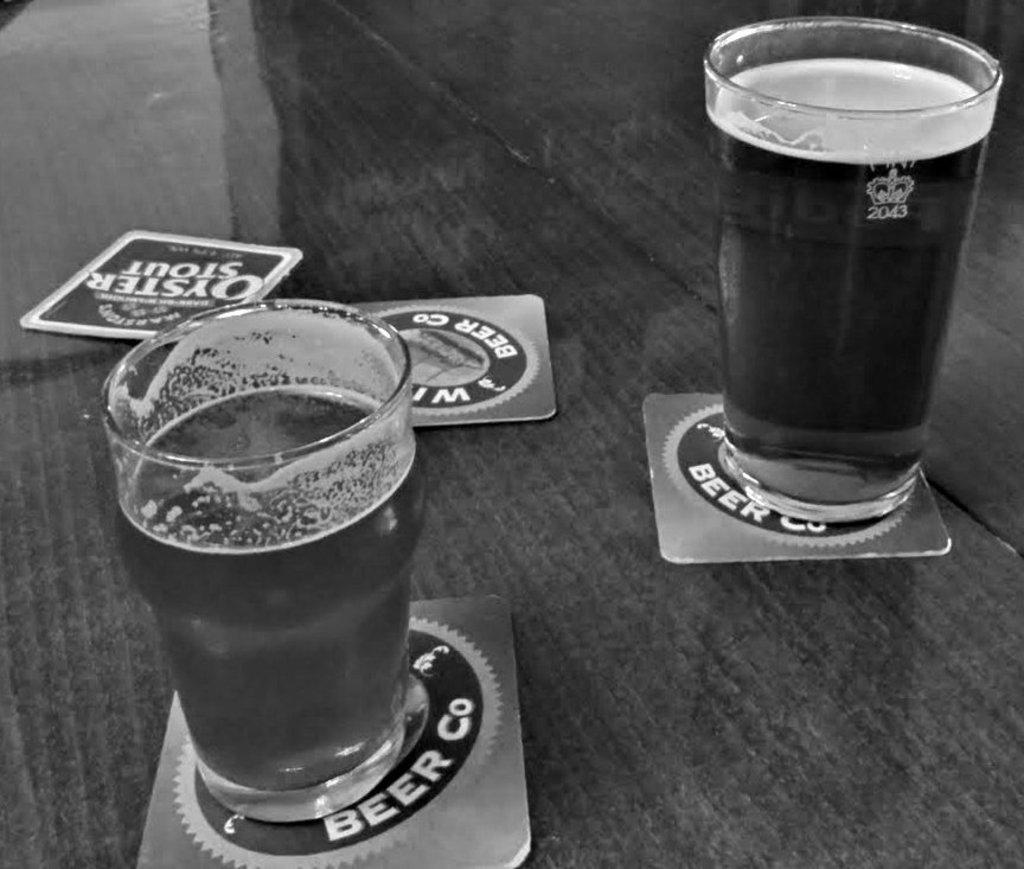What is the color scheme of the image? The image is black and white. What objects can be seen on the table in the image? There are two glasses of liquid and coasters in the image. What shape are the coasters in the image? The coasters in the image are square-shaped. What type of glove is being used to stir the liquid in the glasses? There is no glove present in the image, and the glasses of liquid do not show any stirring activity. 